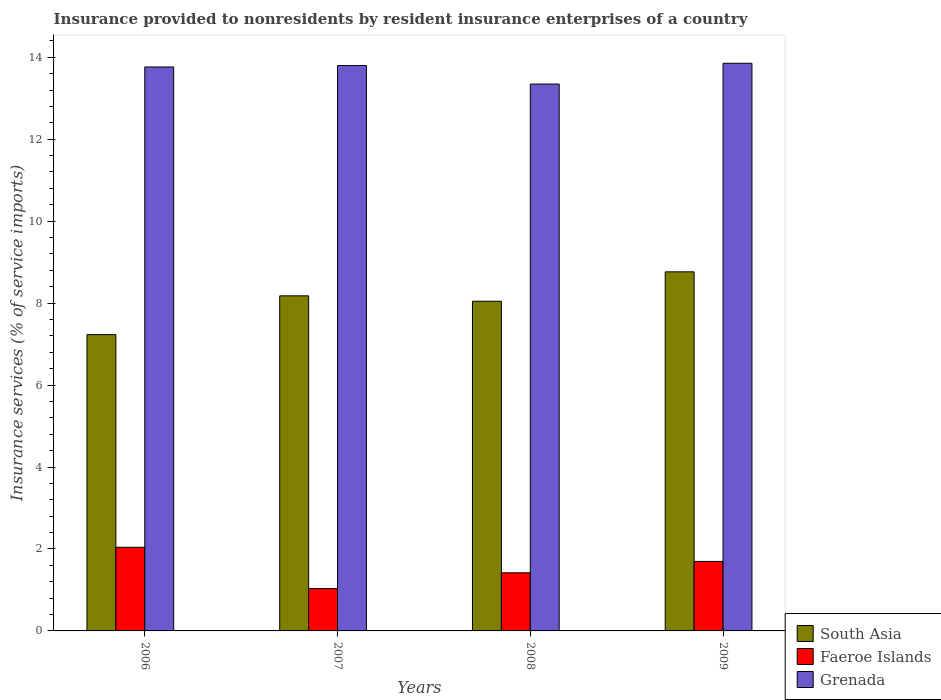How many groups of bars are there?
Keep it short and to the point. 4. Are the number of bars on each tick of the X-axis equal?
Provide a short and direct response. Yes. What is the insurance provided to nonresidents in Faeroe Islands in 2006?
Offer a very short reply. 2.04. Across all years, what is the maximum insurance provided to nonresidents in Faeroe Islands?
Make the answer very short. 2.04. Across all years, what is the minimum insurance provided to nonresidents in Grenada?
Your answer should be compact. 13.35. In which year was the insurance provided to nonresidents in Faeroe Islands maximum?
Offer a very short reply. 2006. In which year was the insurance provided to nonresidents in Faeroe Islands minimum?
Make the answer very short. 2007. What is the total insurance provided to nonresidents in South Asia in the graph?
Your answer should be compact. 32.22. What is the difference between the insurance provided to nonresidents in Grenada in 2006 and that in 2007?
Provide a succinct answer. -0.03. What is the difference between the insurance provided to nonresidents in South Asia in 2009 and the insurance provided to nonresidents in Grenada in 2006?
Provide a succinct answer. -5. What is the average insurance provided to nonresidents in Grenada per year?
Your response must be concise. 13.69. In the year 2009, what is the difference between the insurance provided to nonresidents in South Asia and insurance provided to nonresidents in Faeroe Islands?
Offer a very short reply. 7.07. In how many years, is the insurance provided to nonresidents in South Asia greater than 4.8 %?
Your response must be concise. 4. What is the ratio of the insurance provided to nonresidents in South Asia in 2006 to that in 2009?
Make the answer very short. 0.83. Is the insurance provided to nonresidents in Faeroe Islands in 2007 less than that in 2009?
Provide a short and direct response. Yes. What is the difference between the highest and the second highest insurance provided to nonresidents in Grenada?
Your answer should be very brief. 0.06. What is the difference between the highest and the lowest insurance provided to nonresidents in Faeroe Islands?
Offer a terse response. 1.01. In how many years, is the insurance provided to nonresidents in South Asia greater than the average insurance provided to nonresidents in South Asia taken over all years?
Your answer should be compact. 2. What does the 2nd bar from the left in 2006 represents?
Your answer should be compact. Faeroe Islands. What does the 1st bar from the right in 2008 represents?
Your answer should be compact. Grenada. Is it the case that in every year, the sum of the insurance provided to nonresidents in South Asia and insurance provided to nonresidents in Faeroe Islands is greater than the insurance provided to nonresidents in Grenada?
Your answer should be very brief. No. How many bars are there?
Offer a terse response. 12. Are all the bars in the graph horizontal?
Your answer should be very brief. No. How many years are there in the graph?
Offer a very short reply. 4. What is the difference between two consecutive major ticks on the Y-axis?
Keep it short and to the point. 2. Are the values on the major ticks of Y-axis written in scientific E-notation?
Provide a short and direct response. No. Does the graph contain grids?
Provide a short and direct response. No. How are the legend labels stacked?
Your response must be concise. Vertical. What is the title of the graph?
Your answer should be very brief. Insurance provided to nonresidents by resident insurance enterprises of a country. Does "High income: nonOECD" appear as one of the legend labels in the graph?
Offer a terse response. No. What is the label or title of the Y-axis?
Provide a succinct answer. Insurance services (% of service imports). What is the Insurance services (% of service imports) in South Asia in 2006?
Your answer should be compact. 7.23. What is the Insurance services (% of service imports) of Faeroe Islands in 2006?
Give a very brief answer. 2.04. What is the Insurance services (% of service imports) of Grenada in 2006?
Keep it short and to the point. 13.76. What is the Insurance services (% of service imports) in South Asia in 2007?
Your response must be concise. 8.18. What is the Insurance services (% of service imports) of Faeroe Islands in 2007?
Your answer should be compact. 1.03. What is the Insurance services (% of service imports) in Grenada in 2007?
Give a very brief answer. 13.8. What is the Insurance services (% of service imports) in South Asia in 2008?
Offer a terse response. 8.05. What is the Insurance services (% of service imports) in Faeroe Islands in 2008?
Your answer should be compact. 1.42. What is the Insurance services (% of service imports) of Grenada in 2008?
Offer a very short reply. 13.35. What is the Insurance services (% of service imports) of South Asia in 2009?
Offer a very short reply. 8.76. What is the Insurance services (% of service imports) of Faeroe Islands in 2009?
Your answer should be very brief. 1.7. What is the Insurance services (% of service imports) in Grenada in 2009?
Provide a short and direct response. 13.85. Across all years, what is the maximum Insurance services (% of service imports) in South Asia?
Give a very brief answer. 8.76. Across all years, what is the maximum Insurance services (% of service imports) of Faeroe Islands?
Provide a short and direct response. 2.04. Across all years, what is the maximum Insurance services (% of service imports) of Grenada?
Your answer should be very brief. 13.85. Across all years, what is the minimum Insurance services (% of service imports) of South Asia?
Offer a terse response. 7.23. Across all years, what is the minimum Insurance services (% of service imports) of Faeroe Islands?
Offer a very short reply. 1.03. Across all years, what is the minimum Insurance services (% of service imports) of Grenada?
Provide a succinct answer. 13.35. What is the total Insurance services (% of service imports) in South Asia in the graph?
Provide a succinct answer. 32.22. What is the total Insurance services (% of service imports) of Faeroe Islands in the graph?
Make the answer very short. 6.19. What is the total Insurance services (% of service imports) in Grenada in the graph?
Make the answer very short. 54.76. What is the difference between the Insurance services (% of service imports) of South Asia in 2006 and that in 2007?
Provide a short and direct response. -0.95. What is the difference between the Insurance services (% of service imports) in Faeroe Islands in 2006 and that in 2007?
Offer a terse response. 1.01. What is the difference between the Insurance services (% of service imports) of Grenada in 2006 and that in 2007?
Ensure brevity in your answer.  -0.03. What is the difference between the Insurance services (% of service imports) in South Asia in 2006 and that in 2008?
Keep it short and to the point. -0.81. What is the difference between the Insurance services (% of service imports) in Faeroe Islands in 2006 and that in 2008?
Make the answer very short. 0.62. What is the difference between the Insurance services (% of service imports) of Grenada in 2006 and that in 2008?
Your answer should be very brief. 0.42. What is the difference between the Insurance services (% of service imports) in South Asia in 2006 and that in 2009?
Provide a succinct answer. -1.53. What is the difference between the Insurance services (% of service imports) of Faeroe Islands in 2006 and that in 2009?
Offer a very short reply. 0.35. What is the difference between the Insurance services (% of service imports) of Grenada in 2006 and that in 2009?
Your answer should be compact. -0.09. What is the difference between the Insurance services (% of service imports) in South Asia in 2007 and that in 2008?
Provide a short and direct response. 0.13. What is the difference between the Insurance services (% of service imports) of Faeroe Islands in 2007 and that in 2008?
Give a very brief answer. -0.39. What is the difference between the Insurance services (% of service imports) of Grenada in 2007 and that in 2008?
Make the answer very short. 0.45. What is the difference between the Insurance services (% of service imports) of South Asia in 2007 and that in 2009?
Give a very brief answer. -0.59. What is the difference between the Insurance services (% of service imports) in Faeroe Islands in 2007 and that in 2009?
Ensure brevity in your answer.  -0.66. What is the difference between the Insurance services (% of service imports) of Grenada in 2007 and that in 2009?
Give a very brief answer. -0.06. What is the difference between the Insurance services (% of service imports) of South Asia in 2008 and that in 2009?
Provide a succinct answer. -0.72. What is the difference between the Insurance services (% of service imports) of Faeroe Islands in 2008 and that in 2009?
Keep it short and to the point. -0.28. What is the difference between the Insurance services (% of service imports) in Grenada in 2008 and that in 2009?
Keep it short and to the point. -0.51. What is the difference between the Insurance services (% of service imports) in South Asia in 2006 and the Insurance services (% of service imports) in Faeroe Islands in 2007?
Your answer should be very brief. 6.2. What is the difference between the Insurance services (% of service imports) of South Asia in 2006 and the Insurance services (% of service imports) of Grenada in 2007?
Your response must be concise. -6.57. What is the difference between the Insurance services (% of service imports) of Faeroe Islands in 2006 and the Insurance services (% of service imports) of Grenada in 2007?
Offer a terse response. -11.76. What is the difference between the Insurance services (% of service imports) in South Asia in 2006 and the Insurance services (% of service imports) in Faeroe Islands in 2008?
Offer a very short reply. 5.81. What is the difference between the Insurance services (% of service imports) of South Asia in 2006 and the Insurance services (% of service imports) of Grenada in 2008?
Offer a very short reply. -6.12. What is the difference between the Insurance services (% of service imports) in Faeroe Islands in 2006 and the Insurance services (% of service imports) in Grenada in 2008?
Your answer should be compact. -11.3. What is the difference between the Insurance services (% of service imports) of South Asia in 2006 and the Insurance services (% of service imports) of Faeroe Islands in 2009?
Offer a very short reply. 5.54. What is the difference between the Insurance services (% of service imports) in South Asia in 2006 and the Insurance services (% of service imports) in Grenada in 2009?
Offer a terse response. -6.62. What is the difference between the Insurance services (% of service imports) in Faeroe Islands in 2006 and the Insurance services (% of service imports) in Grenada in 2009?
Give a very brief answer. -11.81. What is the difference between the Insurance services (% of service imports) in South Asia in 2007 and the Insurance services (% of service imports) in Faeroe Islands in 2008?
Make the answer very short. 6.76. What is the difference between the Insurance services (% of service imports) of South Asia in 2007 and the Insurance services (% of service imports) of Grenada in 2008?
Your answer should be compact. -5.17. What is the difference between the Insurance services (% of service imports) in Faeroe Islands in 2007 and the Insurance services (% of service imports) in Grenada in 2008?
Offer a very short reply. -12.31. What is the difference between the Insurance services (% of service imports) of South Asia in 2007 and the Insurance services (% of service imports) of Faeroe Islands in 2009?
Your answer should be compact. 6.48. What is the difference between the Insurance services (% of service imports) in South Asia in 2007 and the Insurance services (% of service imports) in Grenada in 2009?
Give a very brief answer. -5.68. What is the difference between the Insurance services (% of service imports) in Faeroe Islands in 2007 and the Insurance services (% of service imports) in Grenada in 2009?
Keep it short and to the point. -12.82. What is the difference between the Insurance services (% of service imports) in South Asia in 2008 and the Insurance services (% of service imports) in Faeroe Islands in 2009?
Ensure brevity in your answer.  6.35. What is the difference between the Insurance services (% of service imports) of South Asia in 2008 and the Insurance services (% of service imports) of Grenada in 2009?
Your answer should be compact. -5.81. What is the difference between the Insurance services (% of service imports) in Faeroe Islands in 2008 and the Insurance services (% of service imports) in Grenada in 2009?
Your answer should be compact. -12.44. What is the average Insurance services (% of service imports) in South Asia per year?
Provide a short and direct response. 8.05. What is the average Insurance services (% of service imports) in Faeroe Islands per year?
Offer a very short reply. 1.55. What is the average Insurance services (% of service imports) in Grenada per year?
Ensure brevity in your answer.  13.69. In the year 2006, what is the difference between the Insurance services (% of service imports) in South Asia and Insurance services (% of service imports) in Faeroe Islands?
Offer a terse response. 5.19. In the year 2006, what is the difference between the Insurance services (% of service imports) in South Asia and Insurance services (% of service imports) in Grenada?
Ensure brevity in your answer.  -6.53. In the year 2006, what is the difference between the Insurance services (% of service imports) of Faeroe Islands and Insurance services (% of service imports) of Grenada?
Give a very brief answer. -11.72. In the year 2007, what is the difference between the Insurance services (% of service imports) in South Asia and Insurance services (% of service imports) in Faeroe Islands?
Offer a very short reply. 7.15. In the year 2007, what is the difference between the Insurance services (% of service imports) of South Asia and Insurance services (% of service imports) of Grenada?
Ensure brevity in your answer.  -5.62. In the year 2007, what is the difference between the Insurance services (% of service imports) in Faeroe Islands and Insurance services (% of service imports) in Grenada?
Keep it short and to the point. -12.76. In the year 2008, what is the difference between the Insurance services (% of service imports) of South Asia and Insurance services (% of service imports) of Faeroe Islands?
Ensure brevity in your answer.  6.63. In the year 2008, what is the difference between the Insurance services (% of service imports) of South Asia and Insurance services (% of service imports) of Grenada?
Your answer should be very brief. -5.3. In the year 2008, what is the difference between the Insurance services (% of service imports) of Faeroe Islands and Insurance services (% of service imports) of Grenada?
Make the answer very short. -11.93. In the year 2009, what is the difference between the Insurance services (% of service imports) in South Asia and Insurance services (% of service imports) in Faeroe Islands?
Offer a terse response. 7.07. In the year 2009, what is the difference between the Insurance services (% of service imports) of South Asia and Insurance services (% of service imports) of Grenada?
Make the answer very short. -5.09. In the year 2009, what is the difference between the Insurance services (% of service imports) in Faeroe Islands and Insurance services (% of service imports) in Grenada?
Offer a very short reply. -12.16. What is the ratio of the Insurance services (% of service imports) of South Asia in 2006 to that in 2007?
Make the answer very short. 0.88. What is the ratio of the Insurance services (% of service imports) of Faeroe Islands in 2006 to that in 2007?
Provide a short and direct response. 1.98. What is the ratio of the Insurance services (% of service imports) in Grenada in 2006 to that in 2007?
Offer a very short reply. 1. What is the ratio of the Insurance services (% of service imports) in South Asia in 2006 to that in 2008?
Your answer should be very brief. 0.9. What is the ratio of the Insurance services (% of service imports) of Faeroe Islands in 2006 to that in 2008?
Give a very brief answer. 1.44. What is the ratio of the Insurance services (% of service imports) in Grenada in 2006 to that in 2008?
Give a very brief answer. 1.03. What is the ratio of the Insurance services (% of service imports) in South Asia in 2006 to that in 2009?
Keep it short and to the point. 0.83. What is the ratio of the Insurance services (% of service imports) of Faeroe Islands in 2006 to that in 2009?
Provide a short and direct response. 1.2. What is the ratio of the Insurance services (% of service imports) in Grenada in 2006 to that in 2009?
Offer a very short reply. 0.99. What is the ratio of the Insurance services (% of service imports) of South Asia in 2007 to that in 2008?
Your response must be concise. 1.02. What is the ratio of the Insurance services (% of service imports) in Faeroe Islands in 2007 to that in 2008?
Keep it short and to the point. 0.73. What is the ratio of the Insurance services (% of service imports) in Grenada in 2007 to that in 2008?
Your response must be concise. 1.03. What is the ratio of the Insurance services (% of service imports) in South Asia in 2007 to that in 2009?
Make the answer very short. 0.93. What is the ratio of the Insurance services (% of service imports) in Faeroe Islands in 2007 to that in 2009?
Offer a very short reply. 0.61. What is the ratio of the Insurance services (% of service imports) in Grenada in 2007 to that in 2009?
Make the answer very short. 1. What is the ratio of the Insurance services (% of service imports) of South Asia in 2008 to that in 2009?
Your response must be concise. 0.92. What is the ratio of the Insurance services (% of service imports) in Faeroe Islands in 2008 to that in 2009?
Keep it short and to the point. 0.84. What is the ratio of the Insurance services (% of service imports) in Grenada in 2008 to that in 2009?
Offer a very short reply. 0.96. What is the difference between the highest and the second highest Insurance services (% of service imports) of South Asia?
Your answer should be very brief. 0.59. What is the difference between the highest and the second highest Insurance services (% of service imports) of Faeroe Islands?
Make the answer very short. 0.35. What is the difference between the highest and the second highest Insurance services (% of service imports) of Grenada?
Provide a succinct answer. 0.06. What is the difference between the highest and the lowest Insurance services (% of service imports) in South Asia?
Give a very brief answer. 1.53. What is the difference between the highest and the lowest Insurance services (% of service imports) of Faeroe Islands?
Provide a succinct answer. 1.01. What is the difference between the highest and the lowest Insurance services (% of service imports) in Grenada?
Make the answer very short. 0.51. 